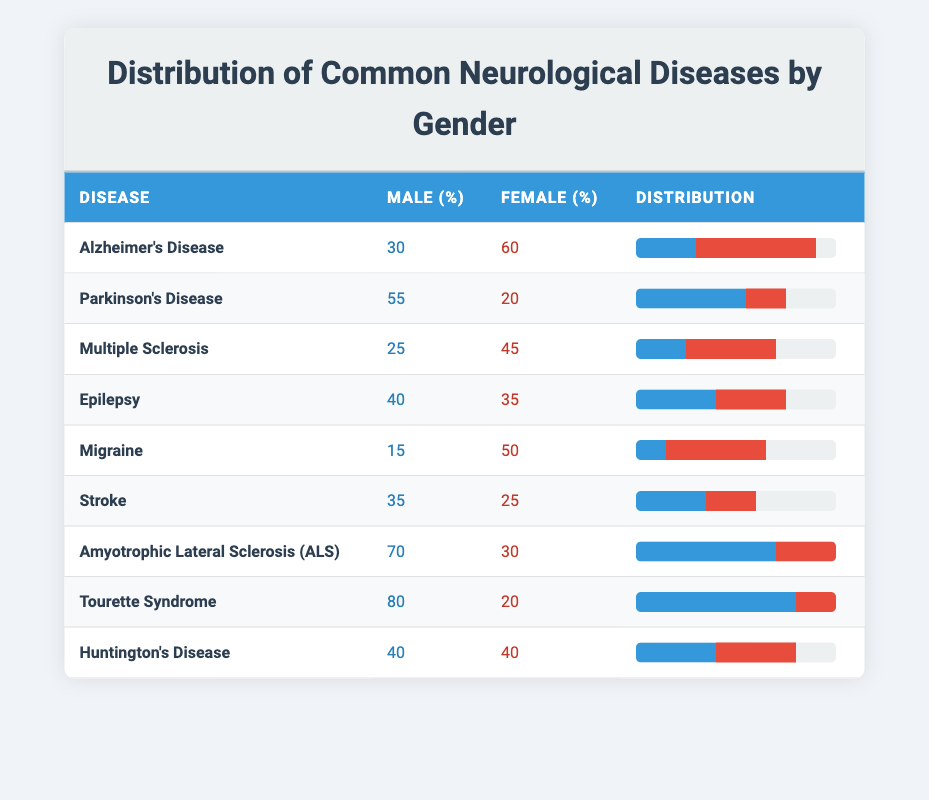What is the percentage of males affected by Alzheimer's Disease? According to the table, the percentage of males affected by Alzheimer's Disease is directly indicated in the "Male (%)" column for that disease, which shows a value of 30%.
Answer: 30% What neurological disease has the highest percentage of females? By examining the "Female (%)" column for each condition, the highest percentage is 60% for Alzheimer's Disease. This is the maximum value among all listed diseases.
Answer: Alzheimer's Disease How many more males than females are affected by Amyotrophic Lateral Sclerosis (ALS)? The table shows that 70 males and 30 females are affected by ALS. The difference is calculated as 70 - 30 = 40. Therefore, 40 more males are affected compared to females.
Answer: 40 What is the average percentage of males across all neurological diseases listed? To find the average percentage of males, add up all the male percentages (30 + 55 + 25 + 40 + 15 + 35 + 70 + 80 + 40 = 350) and divide by the number of diseases (9). So, 350/9 = approximately 38.89.
Answer: 38.89 Is it true that females have a higher percentage of cases in more than 5 neurological diseases? The female percentages for each disease must be examined. They are higher in Alzheimer's Disease, Multiple Sclerosis, Migraine, and Huntington's Disease (4 diseases). Hence, it is false that females have a higher percentage in more than 5 diseases.
Answer: No Which disease has the least difference between male and female percentages? By looking at the absolute differences between male and female percentages: Alzheimer's Disease (30), Parkinson's Disease (35), Multiple Sclerosis (20), Epilepsy (5), Migraine (35), Stroke (10), ALS (40), Tourette Syndrome (60), and Huntington's Disease (0). The least difference is 0%, found in Huntington's Disease.
Answer: Huntington's Disease What percentage of males and females are affected by Tourette Syndrome? The table directly shows that 80% of Tourette Syndrome cases are male, while 20% are female. These values can be found in the respective columns for this disease.
Answer: Males: 80%, Females: 20% How many neurological diseases show a higher prevalence in males compared to females? By checking each disease, we find that Parkinson's Disease, ALS, and Tourette Syndrome have higher male percentages. In total, there are 3 diseases where males are more affected.
Answer: 3 